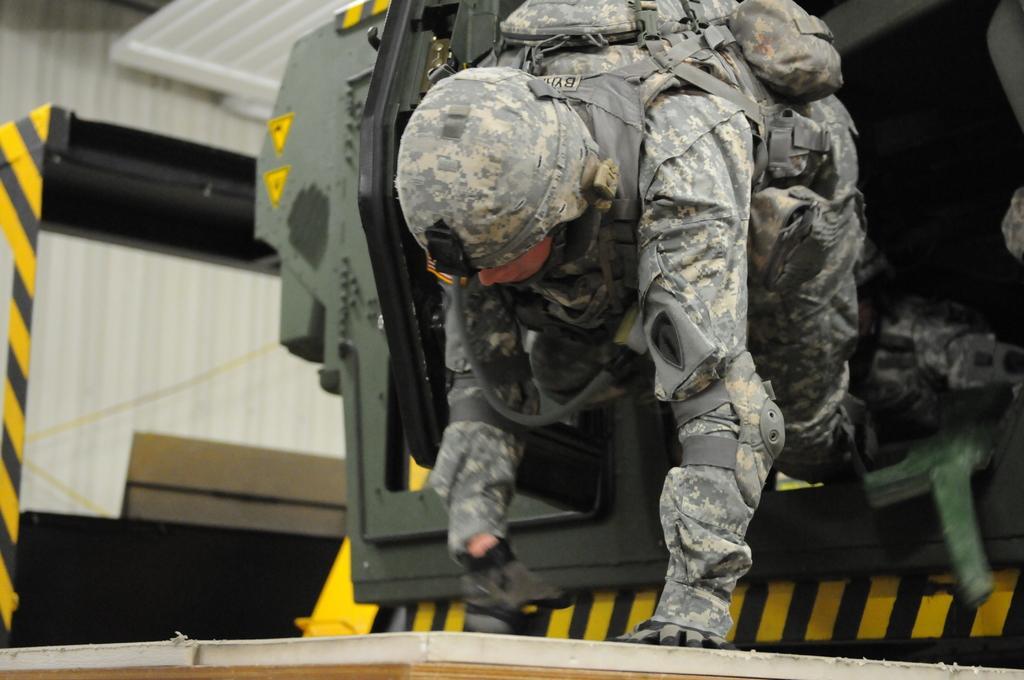Describe this image in one or two sentences. In the center we can see a person wearing uniform and seems to be crawling. In the background we can see many other objects. 